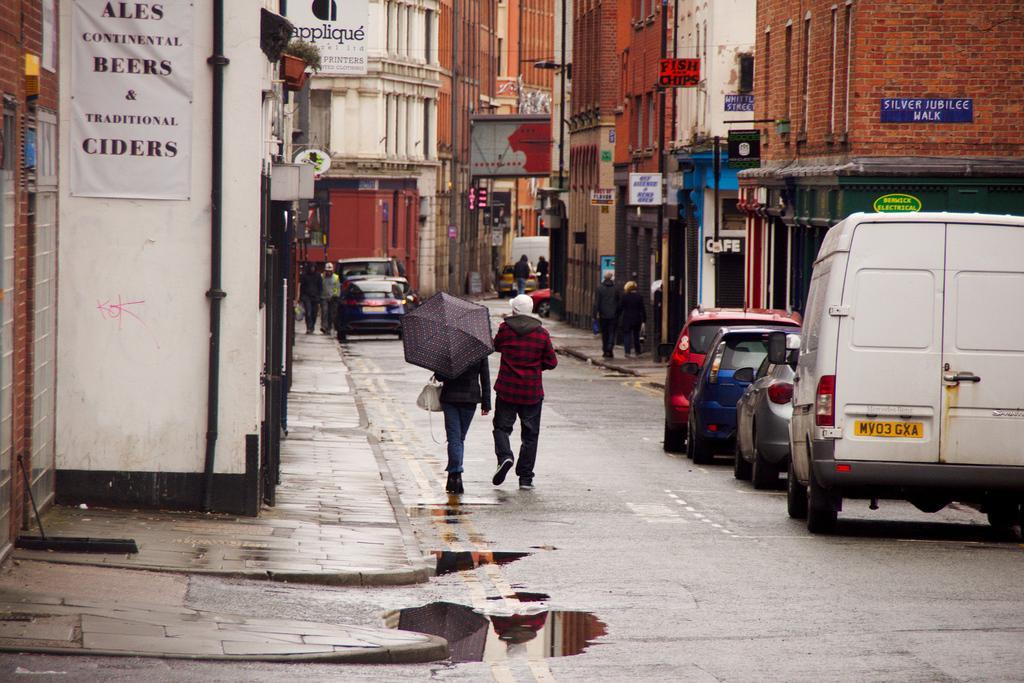Could you give a brief overview of what you see in this image? In the picture we can see a road on it we can see some cars and van are parked beside the path and buildings and beside the cars we can see a man and a woman are walking, woman is with an umbrella and hand bag and beside them we can see a path and far away from it we can see some people are walking on the path and beside them we can see some buildings and in the background also we can see some buildings. 